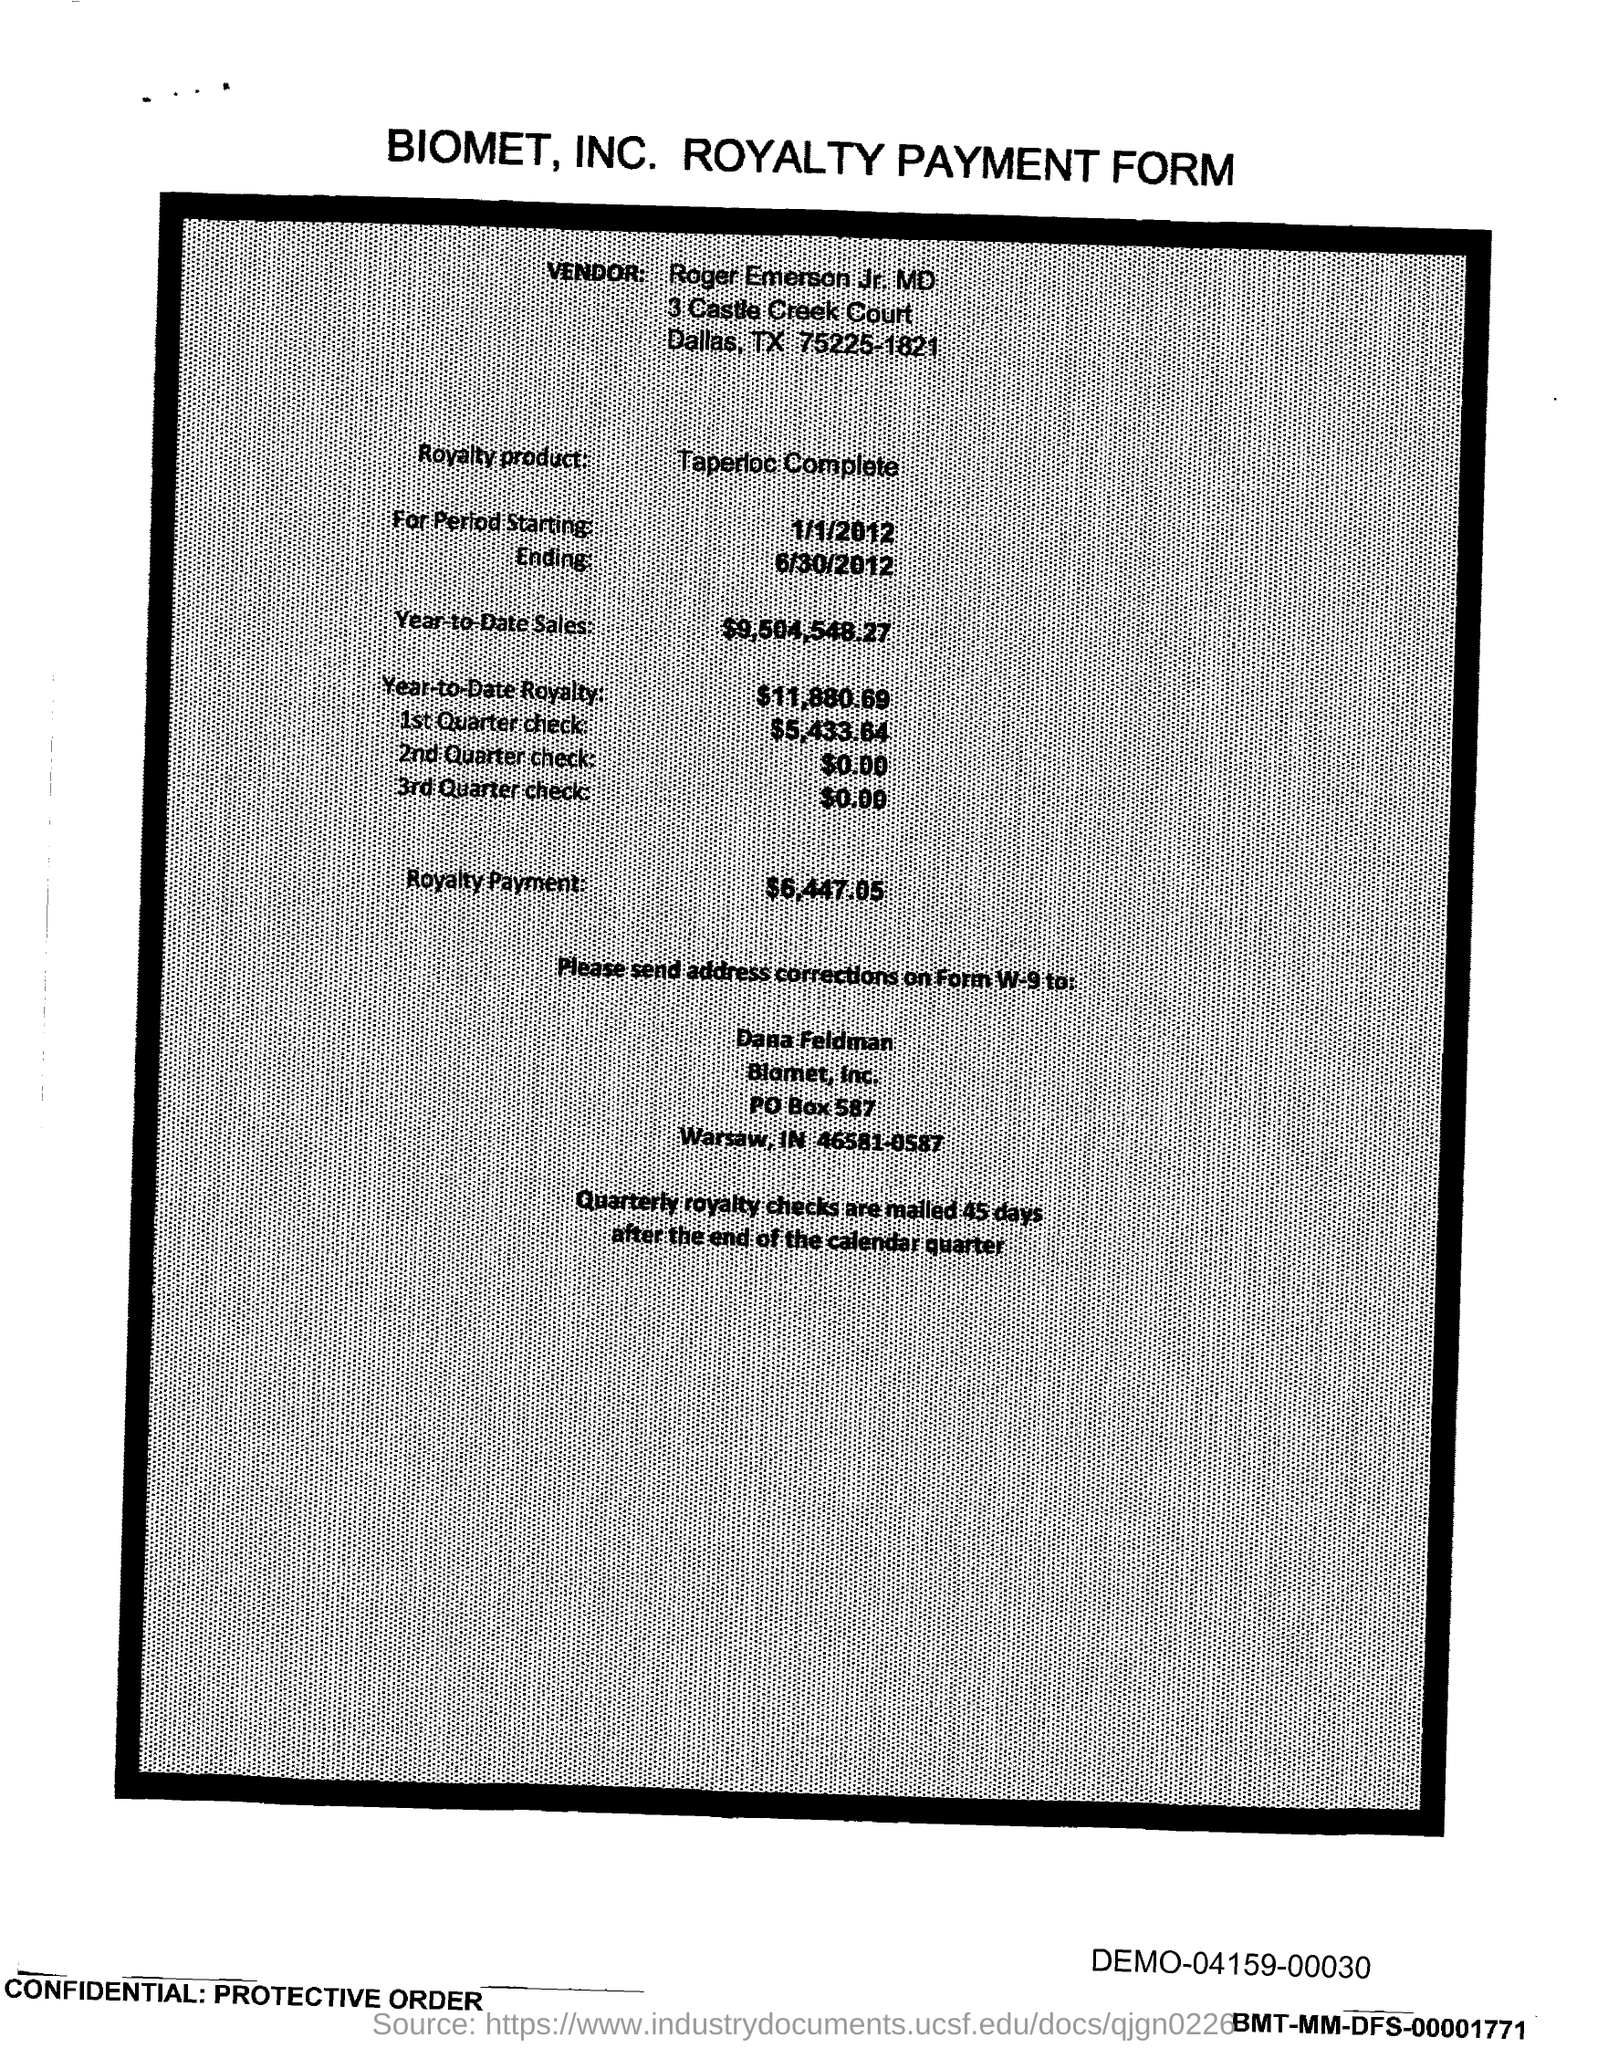Outline some significant characteristics in this image. The PO Box number mentioned in the document is 587. 